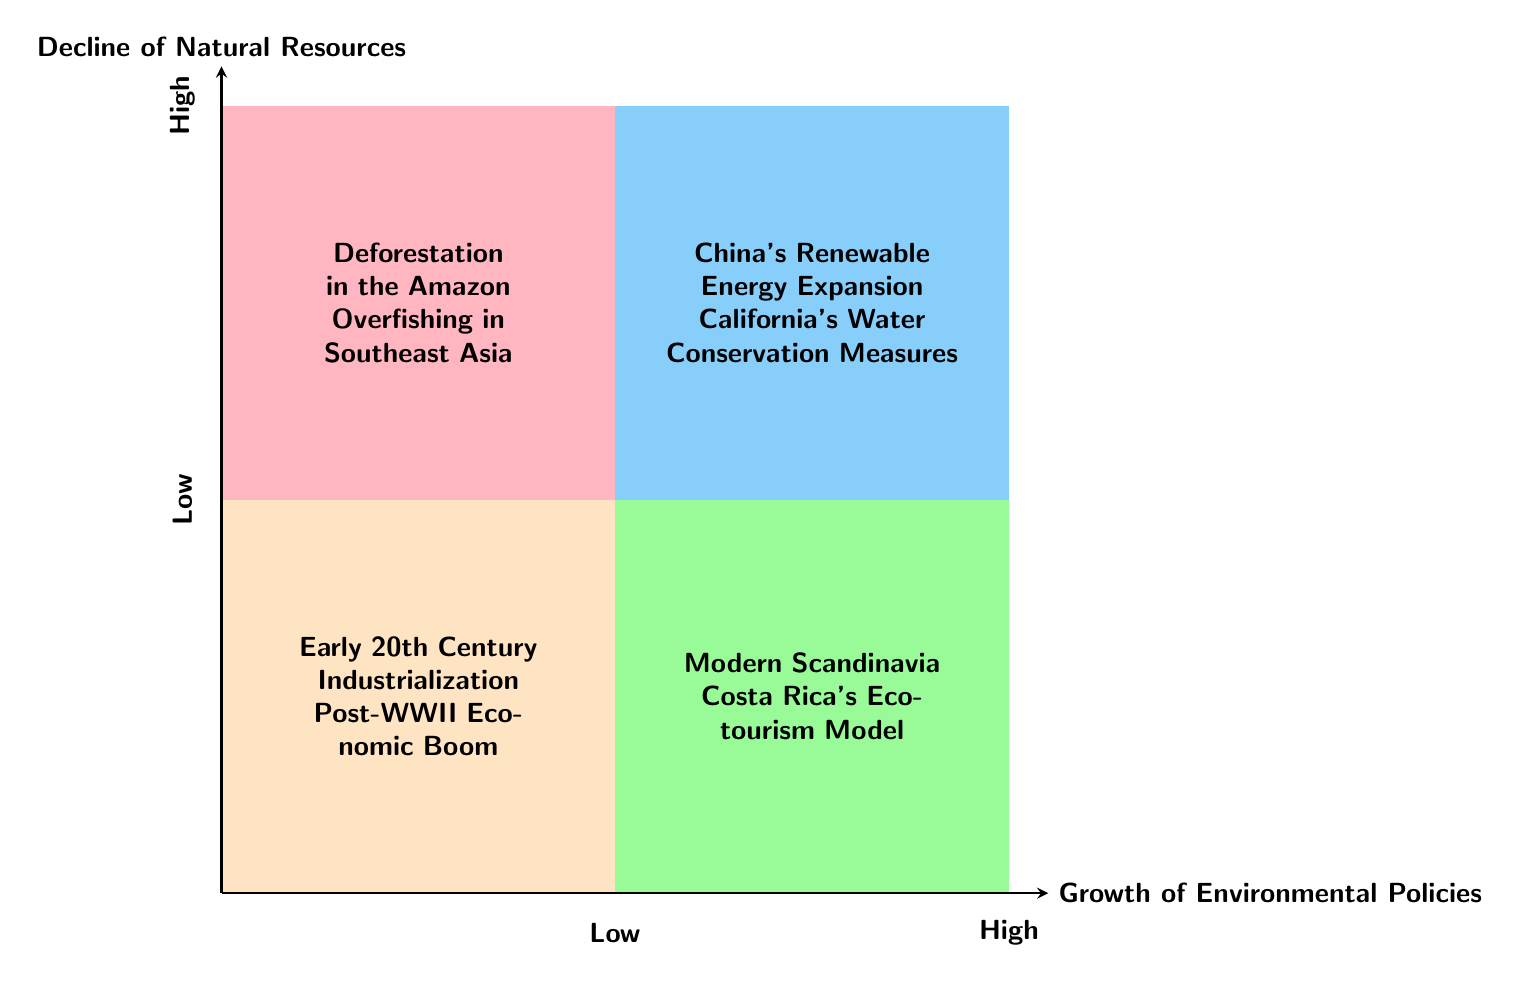What examples are in the Low Decline of Natural Resources, Low Growth of Environmental Policies quadrant? The diagram indicates that this quadrant includes "Early 20th Century Industrialization" and "Post-WWII Economic Boom" as its examples.
Answer: Early 20th Century Industrialization, Post-WWII Economic Boom What is the title of the y-axis? The y-axis represents the "Decline of Natural Resources", as labeled in the diagram.
Answer: Decline of Natural Resources What quadrant features China's Renewable Energy Expansion? The example "China's Renewable Energy Expansion" is located in the quadrant where both the decline of natural resources and growth of environmental policies are high, indicating significant environmental action alongside resource depletion.
Answer: High Decline of Natural Resources, High Growth of Environmental Policies Which region is represented in the Low Decline of Natural Resources, High Growth of Environmental Policies quadrant? The Low Decline of Natural Resources and High Growth of Environmental Policies quadrant includes examples like "Modern Scandinavia" and "Costa Rica's Ecotourism Model", both known for strong environmental policies without significant depletion of resources.
Answer: Modern Scandinavia, Costa Rica's Ecotourism Model What is the relationship between deforestation in the Amazon and environmental policies? Deforestation in the Amazon, found in the High Decline of Natural Resources, Low Growth of Environmental Policies quadrant, suggests a critical situation with high resource depletion but inadequate environmental policies to mitigate it.
Answer: High resource depletion, inadequate policies How many quadrants are represented in the chart? The diagram clearly shows four distinct quadrants. Each quadrant represents a different relationship between the decline of natural resources and the growth of environmental policies.
Answer: Four quadrants What trend is indicated by moving from the bottom left to the top right of the chart? Moving from the bottom left (Low Decline of Natural Resources, Low Growth of Environmental Policies) to the top right (High Decline of Natural Resources, High Growth of Environmental Policies) indicates an increase in both the decline of natural resources and the growth of environmental policies.
Answer: Increasing trends What is the significance of California's Water Conservation Measures in the diagram? California's Water Conservation Measures represent an example in the High Decline of Natural Resources, High Growth of Environmental Policies quadrant, illustrating efforts to address significant resource challenges with progressive environmental policies.
Answer: Significant efforts in resource management 